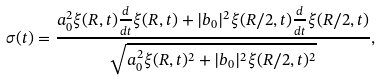Convert formula to latex. <formula><loc_0><loc_0><loc_500><loc_500>\sigma ( t ) = \frac { a _ { 0 } ^ { 2 } \xi ( R , t ) \frac { d } { d t } \xi ( R , t ) + | b _ { 0 } | ^ { 2 } \xi ( R / 2 , t ) \frac { d } { d t } \xi ( R / 2 , t ) } { \sqrt { a _ { 0 } ^ { 2 } \xi ( R , t ) ^ { 2 } + | b _ { 0 } | ^ { 2 } \xi ( R / 2 , t ) ^ { 2 } } } ,</formula> 